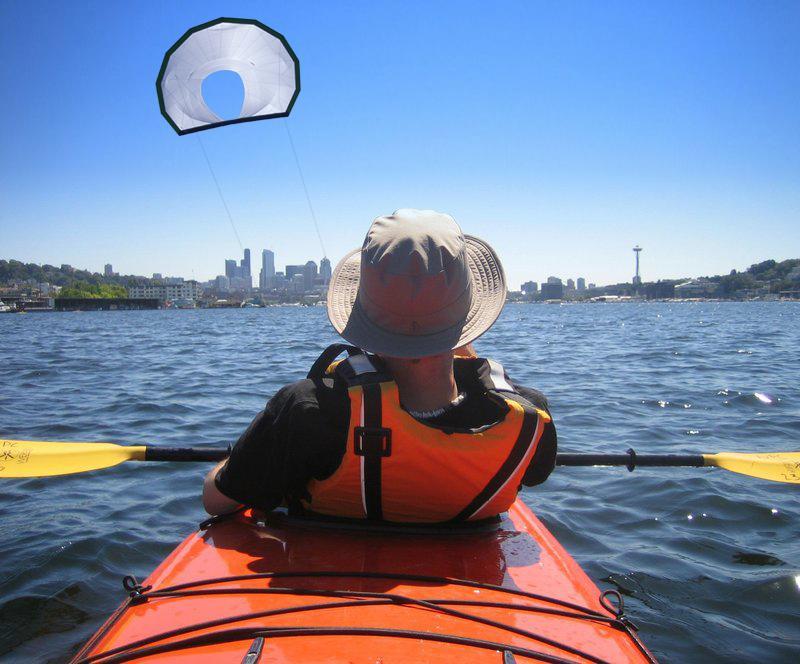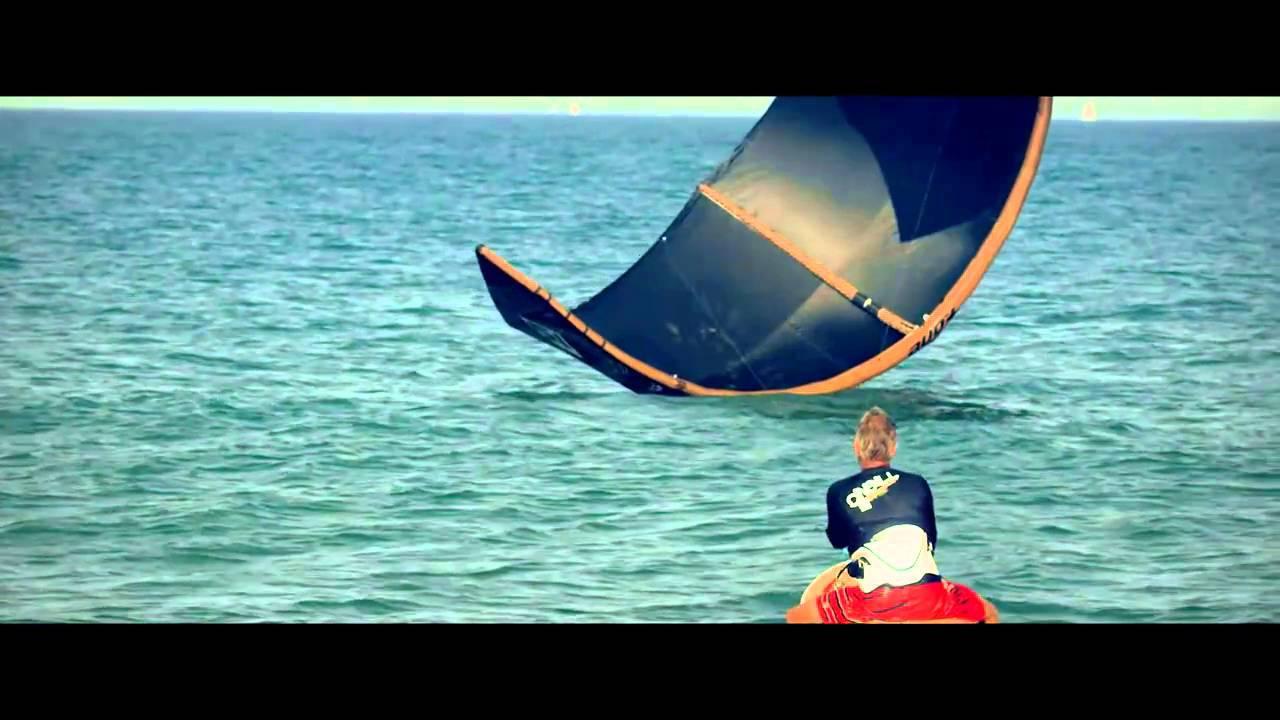The first image is the image on the left, the second image is the image on the right. Considering the images on both sides, is "One of the boats appears to have been grounded on the beach; the boat can easily be used again later." valid? Answer yes or no. No. 